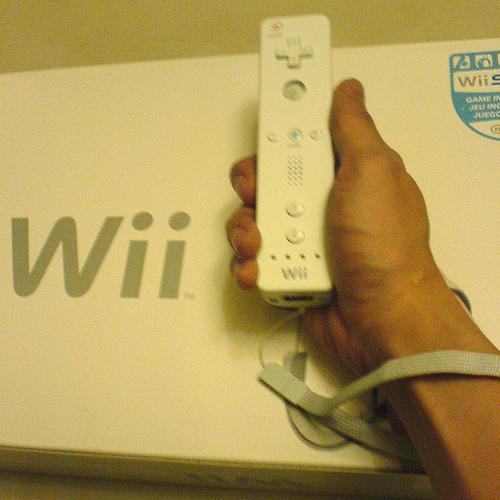How do you pronounce "Wii"?
Quick response, please. We. What is the person holding?
Keep it brief. Game controller. Is this a man or woman's hand?
Be succinct. Man. 